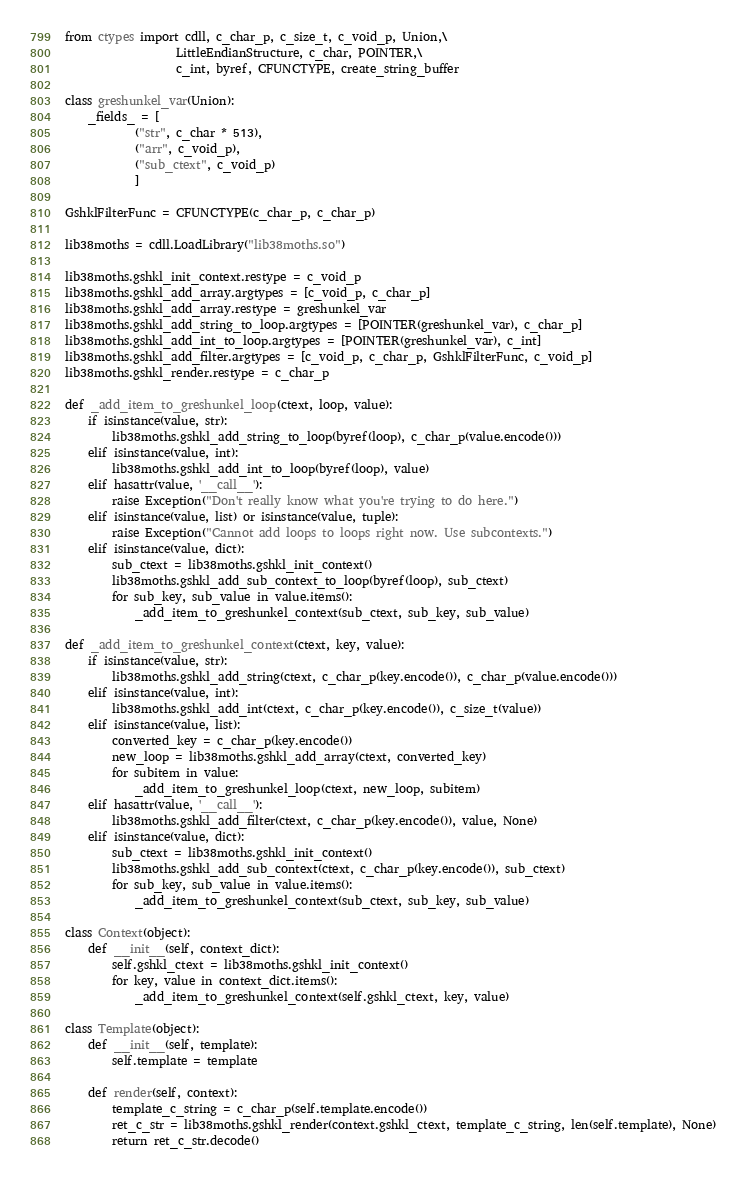Convert code to text. <code><loc_0><loc_0><loc_500><loc_500><_Python_>from ctypes import cdll, c_char_p, c_size_t, c_void_p, Union,\
                   LittleEndianStructure, c_char, POINTER,\
                   c_int, byref, CFUNCTYPE, create_string_buffer

class greshunkel_var(Union):
    _fields_ = [
            ("str", c_char * 513),
            ("arr", c_void_p),
            ("sub_ctext", c_void_p)
            ]

GshklFilterFunc = CFUNCTYPE(c_char_p, c_char_p)

lib38moths = cdll.LoadLibrary("lib38moths.so")

lib38moths.gshkl_init_context.restype = c_void_p
lib38moths.gshkl_add_array.argtypes = [c_void_p, c_char_p]
lib38moths.gshkl_add_array.restype = greshunkel_var
lib38moths.gshkl_add_string_to_loop.argtypes = [POINTER(greshunkel_var), c_char_p]
lib38moths.gshkl_add_int_to_loop.argtypes = [POINTER(greshunkel_var), c_int]
lib38moths.gshkl_add_filter.argtypes = [c_void_p, c_char_p, GshklFilterFunc, c_void_p]
lib38moths.gshkl_render.restype = c_char_p

def _add_item_to_greshunkel_loop(ctext, loop, value):
    if isinstance(value, str):
        lib38moths.gshkl_add_string_to_loop(byref(loop), c_char_p(value.encode()))
    elif isinstance(value, int):
        lib38moths.gshkl_add_int_to_loop(byref(loop), value)
    elif hasattr(value, '__call__'):
        raise Exception("Don't really know what you're trying to do here.")
    elif isinstance(value, list) or isinstance(value, tuple):
        raise Exception("Cannot add loops to loops right now. Use subcontexts.")
    elif isinstance(value, dict):
        sub_ctext = lib38moths.gshkl_init_context()
        lib38moths.gshkl_add_sub_context_to_loop(byref(loop), sub_ctext)
        for sub_key, sub_value in value.items():
            _add_item_to_greshunkel_context(sub_ctext, sub_key, sub_value)

def _add_item_to_greshunkel_context(ctext, key, value):
    if isinstance(value, str):
        lib38moths.gshkl_add_string(ctext, c_char_p(key.encode()), c_char_p(value.encode()))
    elif isinstance(value, int):
        lib38moths.gshkl_add_int(ctext, c_char_p(key.encode()), c_size_t(value))
    elif isinstance(value, list):
        converted_key = c_char_p(key.encode())
        new_loop = lib38moths.gshkl_add_array(ctext, converted_key)
        for subitem in value:
            _add_item_to_greshunkel_loop(ctext, new_loop, subitem)
    elif hasattr(value, '__call__'):
        lib38moths.gshkl_add_filter(ctext, c_char_p(key.encode()), value, None)
    elif isinstance(value, dict):
        sub_ctext = lib38moths.gshkl_init_context()
        lib38moths.gshkl_add_sub_context(ctext, c_char_p(key.encode()), sub_ctext)
        for sub_key, sub_value in value.items():
            _add_item_to_greshunkel_context(sub_ctext, sub_key, sub_value)

class Context(object):
    def __init__(self, context_dict):
        self.gshkl_ctext = lib38moths.gshkl_init_context()
        for key, value in context_dict.items():
            _add_item_to_greshunkel_context(self.gshkl_ctext, key, value)

class Template(object):
    def __init__(self, template):
        self.template = template

    def render(self, context):
        template_c_string = c_char_p(self.template.encode())
        ret_c_str = lib38moths.gshkl_render(context.gshkl_ctext, template_c_string, len(self.template), None)
        return ret_c_str.decode()
</code> 